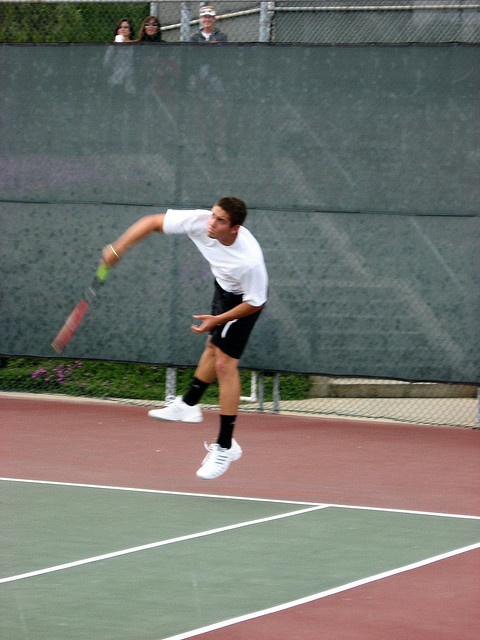Describe the objects in this image and their specific colors. I can see people in darkgray, lavender, black, brown, and gray tones, tennis racket in darkgray, gray, brown, olive, and purple tones, people in darkgray, gray, brown, and lightgray tones, people in darkgray, black, maroon, gray, and brown tones, and people in darkgray, black, gray, white, and brown tones in this image. 